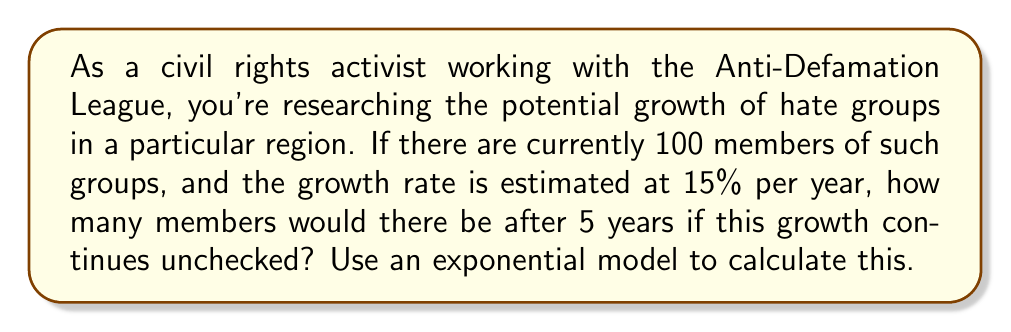Teach me how to tackle this problem. To solve this problem, we'll use the exponential growth model:

$$A = P(1 + r)^t$$

Where:
$A$ = final amount
$P$ = initial population
$r$ = growth rate (as a decimal)
$t$ = time in years

Given:
$P = 100$ (initial members)
$r = 0.15$ (15% growth rate)
$t = 5$ years

Let's plug these values into our equation:

$$A = 100(1 + 0.15)^5$$

Now, let's solve step-by-step:

1) First, calculate $(1 + 0.15)$:
   $1 + 0.15 = 1.15$

2) Now, our equation looks like:
   $$A = 100(1.15)^5$$

3) Calculate $(1.15)^5$:
   $(1.15)^5 \approx 2.0113689$

4) Finally, multiply by 100:
   $$A = 100 \times 2.0113689 \approx 201.13689$$

5) Round to the nearest whole number, as we can't have fractional people:
   $$A \approx 201$$
Answer: After 5 years, there would be approximately 201 members in these hate groups if the 15% annual growth rate continues unchecked. 